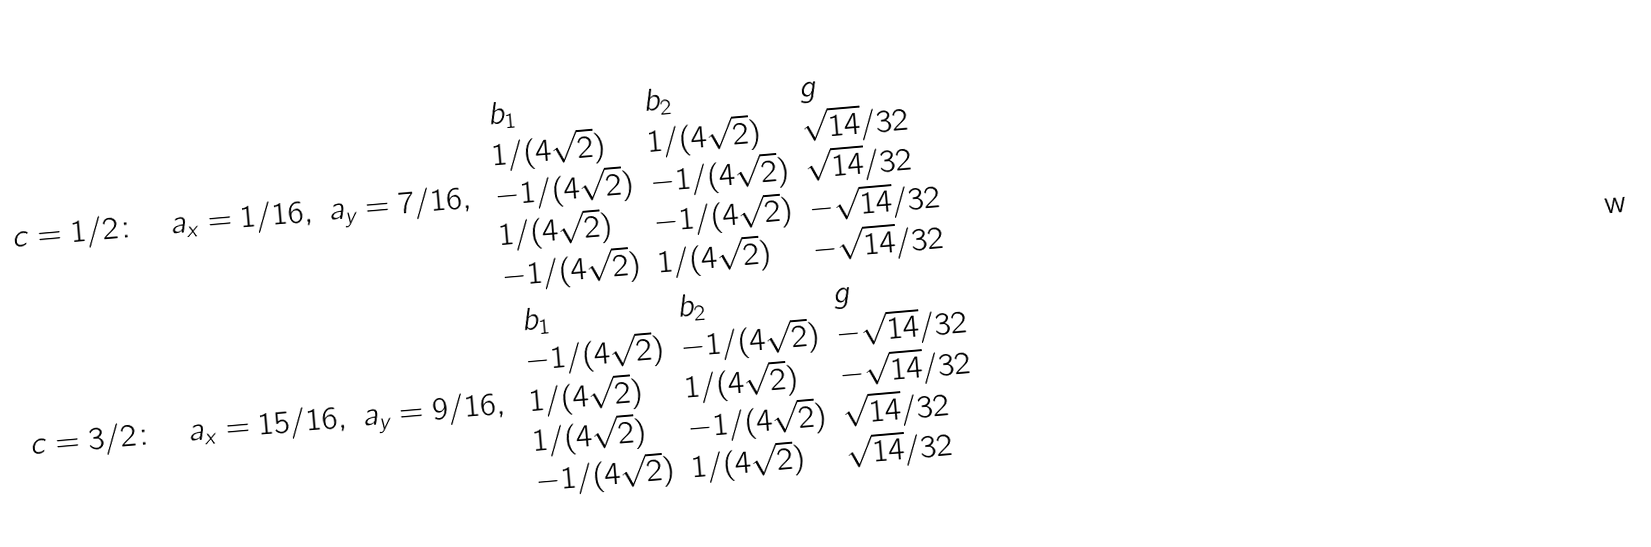Convert formula to latex. <formula><loc_0><loc_0><loc_500><loc_500>c = 1 / 2 \colon & \quad a _ { x } = 1 / 1 6 , \ a _ { y } = 7 / 1 6 , \ \begin{array} { l l l } b _ { 1 } & b _ { 2 } & g \\ 1 / ( 4 \sqrt { 2 } ) & 1 / ( 4 \sqrt { 2 } ) & \sqrt { 1 4 } / 3 2 \\ - 1 / ( 4 \sqrt { 2 } ) & - 1 / ( 4 \sqrt { 2 } ) & \sqrt { 1 4 } / 3 2 \\ 1 / ( 4 \sqrt { 2 } ) & - 1 / ( 4 \sqrt { 2 } ) & - \sqrt { 1 4 } / 3 2 \\ - 1 / ( 4 \sqrt { 2 } ) & 1 / ( 4 \sqrt { 2 } ) & - \sqrt { 1 4 } / 3 2 \\ \end{array} \\ c = 3 / 2 \colon & \quad a _ { x } = 1 5 / 1 6 , \ a _ { y } = 9 / 1 6 , \ \begin{array} { l l l } b _ { 1 } & b _ { 2 } & g \\ - 1 / ( 4 \sqrt { 2 } ) & - 1 / ( 4 \sqrt { 2 } ) & - \sqrt { 1 4 } / 3 2 \\ 1 / ( 4 \sqrt { 2 } ) & 1 / ( 4 \sqrt { 2 } ) & - \sqrt { 1 4 } / 3 2 \\ 1 / ( 4 \sqrt { 2 } ) & - 1 / ( 4 \sqrt { 2 } ) & \sqrt { 1 4 } / 3 2 \\ - 1 / ( 4 \sqrt { 2 } ) & 1 / ( 4 \sqrt { 2 } ) & \sqrt { 1 4 } / 3 2 \\ \end{array}</formula> 